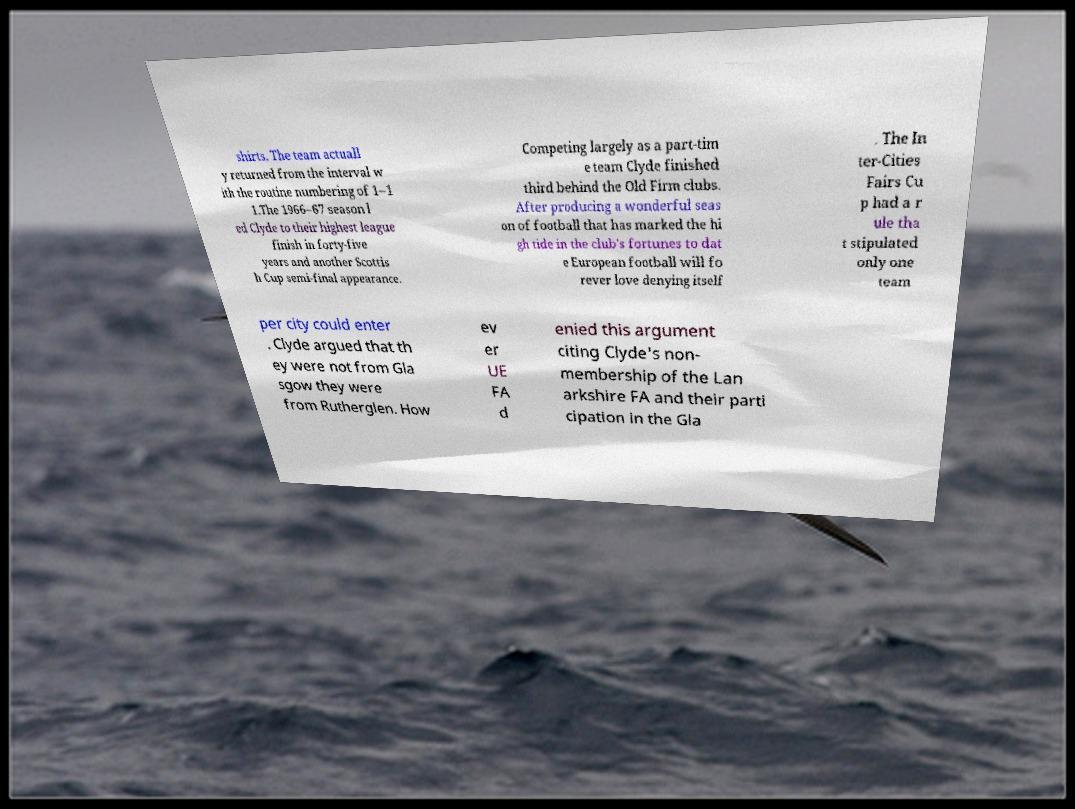Can you read and provide the text displayed in the image?This photo seems to have some interesting text. Can you extract and type it out for me? shirts. The team actuall y returned from the interval w ith the routine numbering of 1–1 1.The 1966–67 season l ed Clyde to their highest league finish in forty-five years and another Scottis h Cup semi-final appearance. Competing largely as a part-tim e team Clyde finished third behind the Old Firm clubs. After producing a wonderful seas on of football that has marked the hi gh tide in the club's fortunes to dat e European football will fo rever love denying itself . The In ter-Cities Fairs Cu p had a r ule tha t stipulated only one team per city could enter . Clyde argued that th ey were not from Gla sgow they were from Rutherglen. How ev er UE FA d enied this argument citing Clyde's non- membership of the Lan arkshire FA and their parti cipation in the Gla 